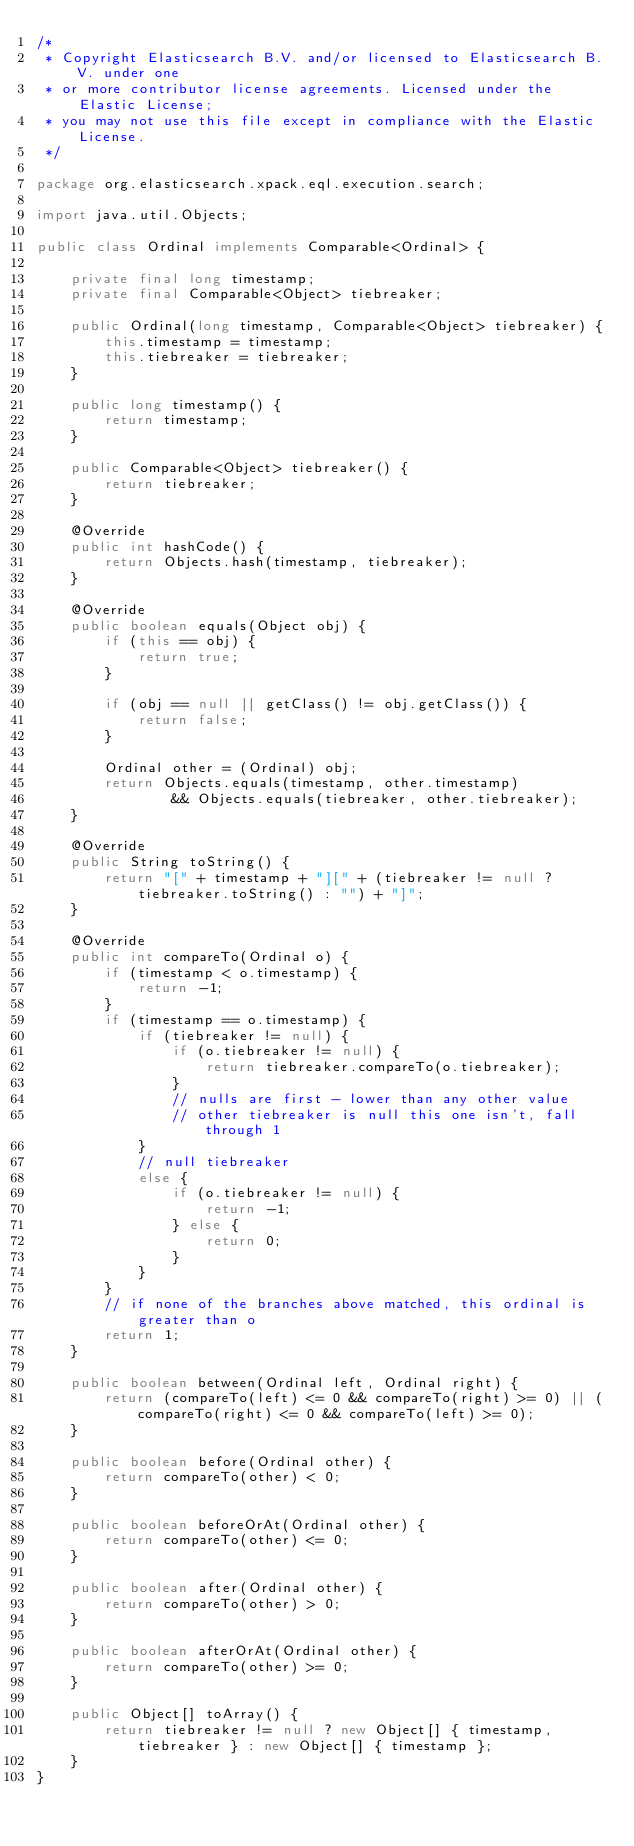Convert code to text. <code><loc_0><loc_0><loc_500><loc_500><_Java_>/*
 * Copyright Elasticsearch B.V. and/or licensed to Elasticsearch B.V. under one
 * or more contributor license agreements. Licensed under the Elastic License;
 * you may not use this file except in compliance with the Elastic License.
 */

package org.elasticsearch.xpack.eql.execution.search;

import java.util.Objects;

public class Ordinal implements Comparable<Ordinal> {

    private final long timestamp;
    private final Comparable<Object> tiebreaker;

    public Ordinal(long timestamp, Comparable<Object> tiebreaker) {
        this.timestamp = timestamp;
        this.tiebreaker = tiebreaker;
    }

    public long timestamp() {
        return timestamp;
    }

    public Comparable<Object> tiebreaker() {
        return tiebreaker;
    }

    @Override
    public int hashCode() {
        return Objects.hash(timestamp, tiebreaker);
    }

    @Override
    public boolean equals(Object obj) {
        if (this == obj) {
            return true;
        }

        if (obj == null || getClass() != obj.getClass()) {
            return false;
        }

        Ordinal other = (Ordinal) obj;
        return Objects.equals(timestamp, other.timestamp)
                && Objects.equals(tiebreaker, other.tiebreaker);
    }

    @Override
    public String toString() {
        return "[" + timestamp + "][" + (tiebreaker != null ? tiebreaker.toString() : "") + "]";
    }

    @Override
    public int compareTo(Ordinal o) {
        if (timestamp < o.timestamp) {
            return -1;
        }
        if (timestamp == o.timestamp) {
            if (tiebreaker != null) {
                if (o.tiebreaker != null) {
                    return tiebreaker.compareTo(o.tiebreaker);
                }
                // nulls are first - lower than any other value
                // other tiebreaker is null this one isn't, fall through 1
            }
            // null tiebreaker
            else {
                if (o.tiebreaker != null) {
                    return -1;
                } else {
                    return 0;
                }
            }
        }
        // if none of the branches above matched, this ordinal is greater than o
        return 1;
    }

    public boolean between(Ordinal left, Ordinal right) {
        return (compareTo(left) <= 0 && compareTo(right) >= 0) || (compareTo(right) <= 0 && compareTo(left) >= 0);
    }

    public boolean before(Ordinal other) {
        return compareTo(other) < 0;
    }

    public boolean beforeOrAt(Ordinal other) {
        return compareTo(other) <= 0;
    }

    public boolean after(Ordinal other) {
        return compareTo(other) > 0;
    }

    public boolean afterOrAt(Ordinal other) {
        return compareTo(other) >= 0;
    }

    public Object[] toArray() {
        return tiebreaker != null ? new Object[] { timestamp, tiebreaker } : new Object[] { timestamp };
    }
}
</code> 